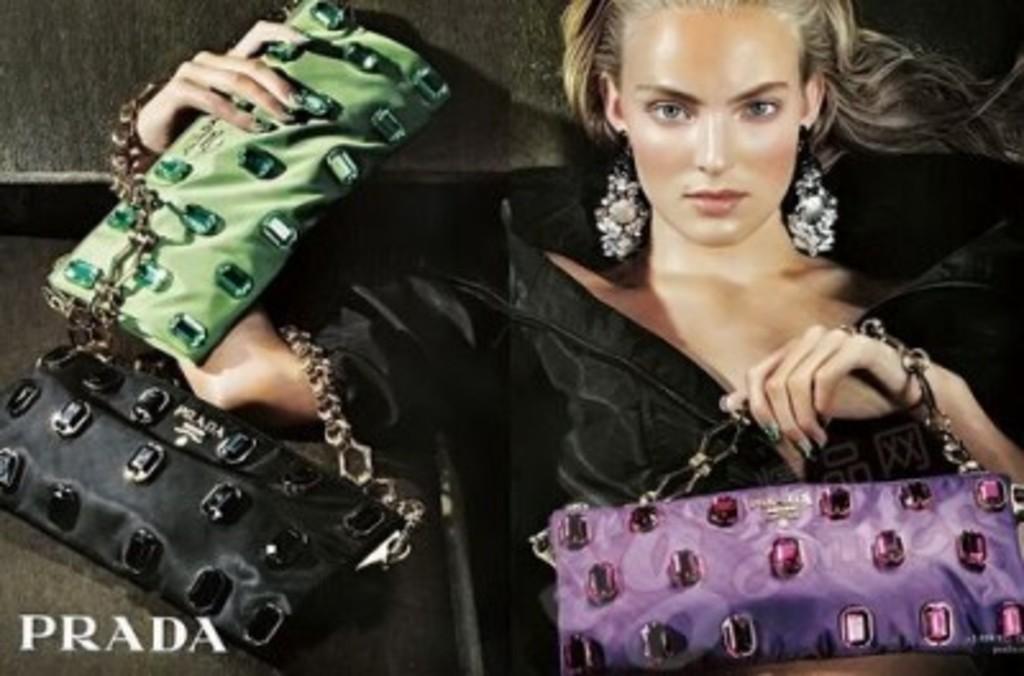Can you describe this image briefly? In this picture the lady is holding three wallets. In her right hand she is holding a green color wallet and a black color wallet. To her left hand she is wearing a violet color wallet. She is wearing a black dress. And her are very big with the stones. 